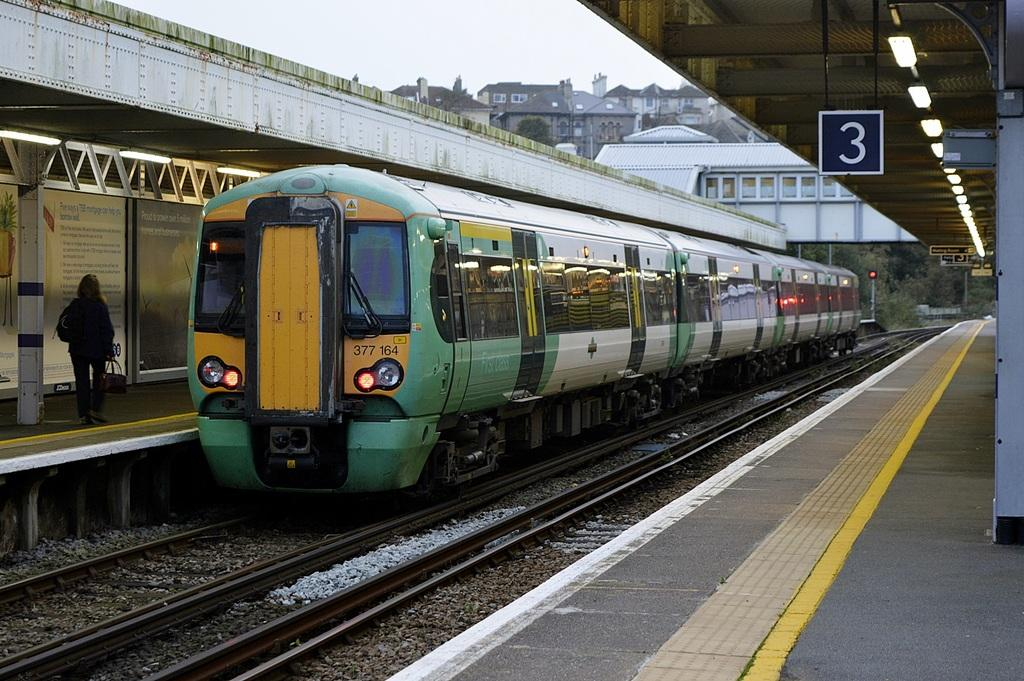<image>
Give a short and clear explanation of the subsequent image. A green train arrives across the 3 platform. 